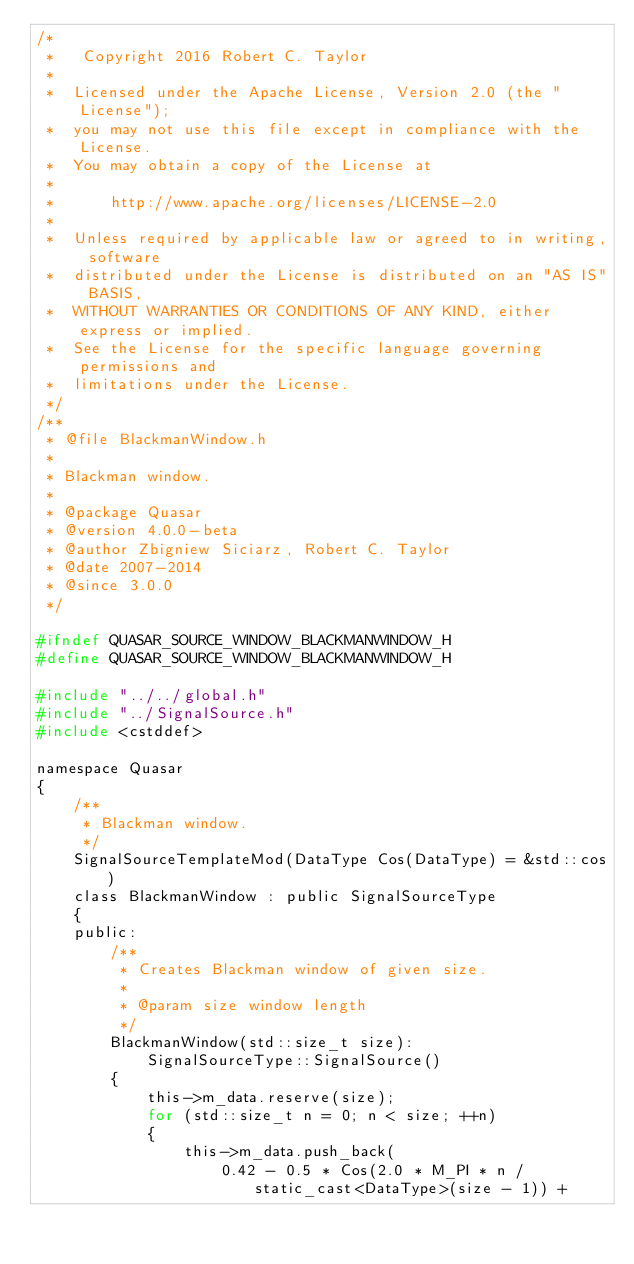<code> <loc_0><loc_0><loc_500><loc_500><_C_>/*
 *   Copyright 2016 Robert C. Taylor
 *
 *  Licensed under the Apache License, Version 2.0 (the "License");
 *  you may not use this file except in compliance with the License.
 *  You may obtain a copy of the License at
 *
 *      http://www.apache.org/licenses/LICENSE-2.0
 *
 *  Unless required by applicable law or agreed to in writing, software
 *  distributed under the License is distributed on an "AS IS" BASIS,
 *  WITHOUT WARRANTIES OR CONDITIONS OF ANY KIND, either express or implied.
 *  See the License for the specific language governing permissions and
 *  limitations under the License.
 */
/**
 * @file BlackmanWindow.h
 *
 * Blackman window.
 *
 * @package Quasar
 * @version 4.0.0-beta
 * @author Zbigniew Siciarz, Robert C. Taylor
 * @date 2007-2014
 * @since 3.0.0
 */

#ifndef QUASAR_SOURCE_WINDOW_BLACKMANWINDOW_H
#define QUASAR_SOURCE_WINDOW_BLACKMANWINDOW_H

#include "../../global.h"
#include "../SignalSource.h"
#include <cstddef>

namespace Quasar
{
    /**
     * Blackman window.
     */
	SignalSourceTemplateMod(DataType Cos(DataType) = &std::cos)
    class BlackmanWindow : public SignalSourceType
    {
    public:
        /**
         * Creates Blackman window of given size.
         *
         * @param size window length
         */
        BlackmanWindow(std::size_t size):
            SignalSourceType::SignalSource()
        {
            this->m_data.reserve(size);
            for (std::size_t n = 0; n < size; ++n)
            {
                this->m_data.push_back(
                    0.42 - 0.5 * Cos(2.0 * M_PI * n / static_cast<DataType>(size - 1)) +</code> 